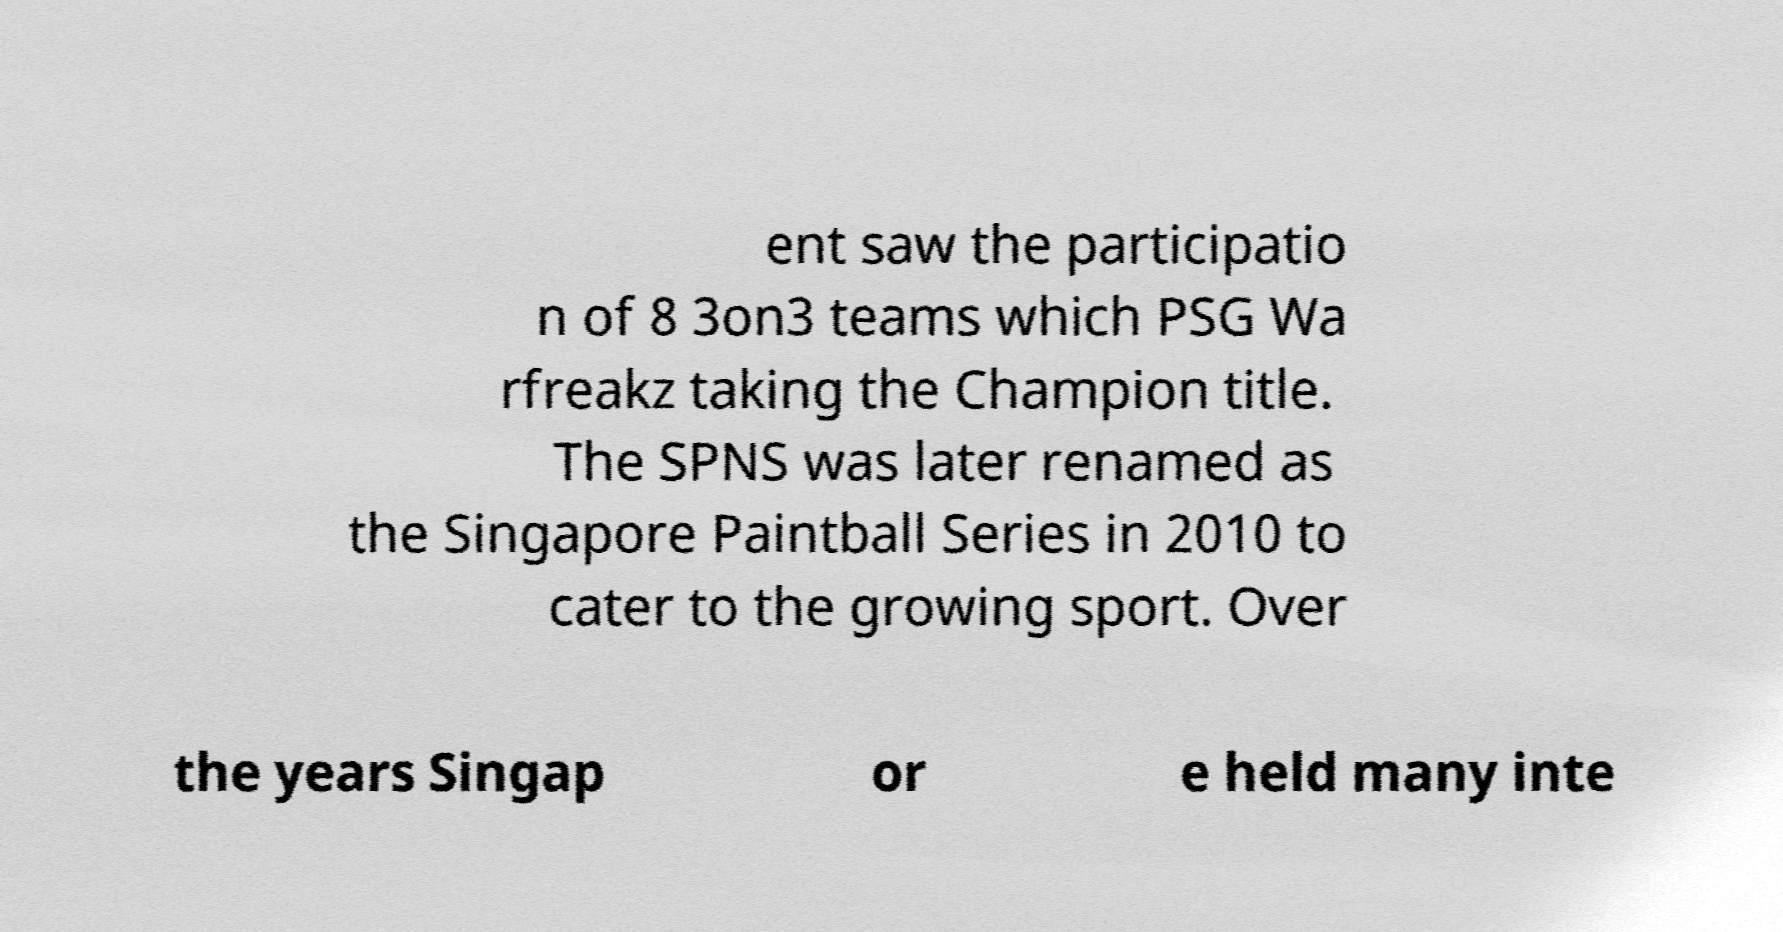What messages or text are displayed in this image? I need them in a readable, typed format. ent saw the participatio n of 8 3on3 teams which PSG Wa rfreakz taking the Champion title. The SPNS was later renamed as the Singapore Paintball Series in 2010 to cater to the growing sport. Over the years Singap or e held many inte 